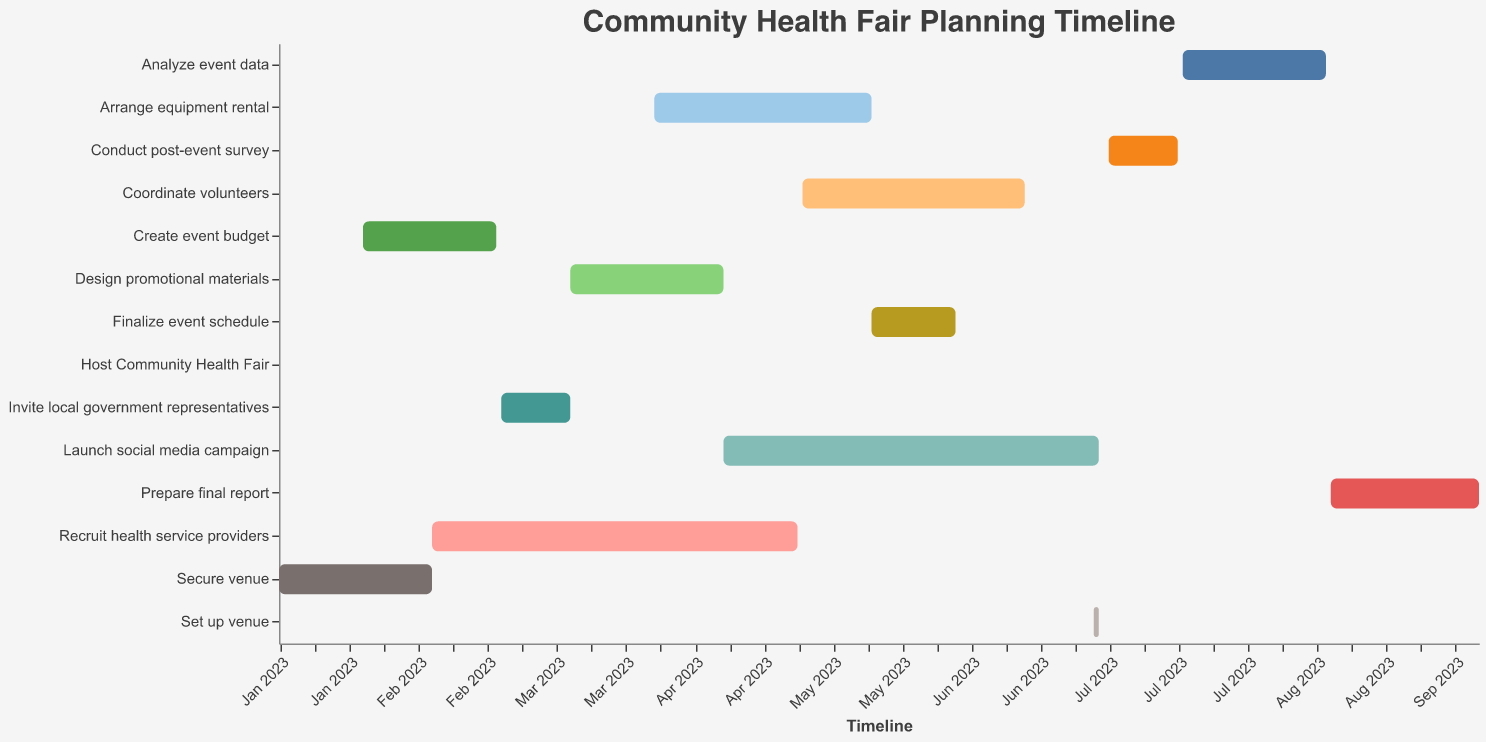What is the duration of the "Secure venue" task? Identify the "Secure venue" task in the Gantt chart and check the duration column.
Answer: 31 days When does the "Launch social media campaign" task begin and end? Locate the "Launch social media campaign" task and refer to the start and end dates within the bar.
Answer: Starts on April 15, 2023, and ends on June 30, 2023 Which tasks overlap with "Design promotional materials"? Examine the duration of the "Design promotional materials" task (March 15, 2023, to April 15, 2023) and see which other tasks' timeframes intersect with it.
Answer: Recruit health service providers and Invite local government representatives How many days after the "Finalize event schedule" task does the "Set up venue" task start? Determine the end date of "Finalize event schedule" (June 1, 2023) and the start date of "Set up venue" (June 29, 2023) and calculate the difference between these dates.
Answer: 28 days What is the total duration for the tasks within the "Recruit health service providers," "Coordinate volunteers," and "Launch social media campaign"? Sum the durations of these three tasks: Recruit health service providers (74 days), Coordinate volunteers (45 days), and Launch social media campaign (76 days). Add these values together.
Answer: 195 days Which task has the shortest duration and how long is it? Identify the task with the minimum duration. In this chart, look for the smallest span in the plot and check the corresponding duration.
Answer: Set up venue, 1 day What is the time gap between the start of "Analyze event data" and the end of "Post-event survey"? Determine when the "Post-event survey" ends (July 16, 2023) and when "Analyze event data" starts (July 17, 2023), then compute the difference between these dates.
Answer: 1 day During which month does the "Create event budget" task entirely take place? Look at the date range for the "Create event budget" task (February 1, 2023, to February 28, 2023) and identify the corresponding month.
Answer: February 2023 